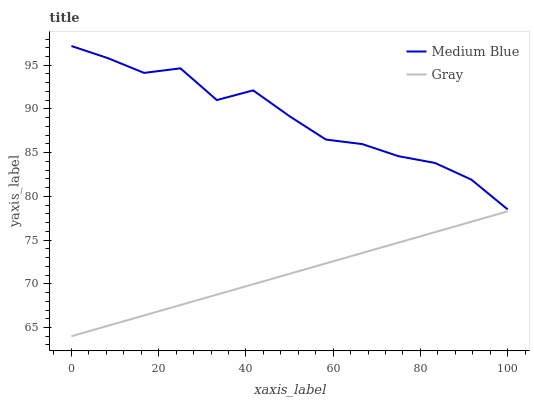Does Gray have the minimum area under the curve?
Answer yes or no. Yes. Does Medium Blue have the maximum area under the curve?
Answer yes or no. Yes. Does Medium Blue have the minimum area under the curve?
Answer yes or no. No. Is Gray the smoothest?
Answer yes or no. Yes. Is Medium Blue the roughest?
Answer yes or no. Yes. Is Medium Blue the smoothest?
Answer yes or no. No. Does Medium Blue have the lowest value?
Answer yes or no. No. Is Gray less than Medium Blue?
Answer yes or no. Yes. Is Medium Blue greater than Gray?
Answer yes or no. Yes. Does Gray intersect Medium Blue?
Answer yes or no. No. 